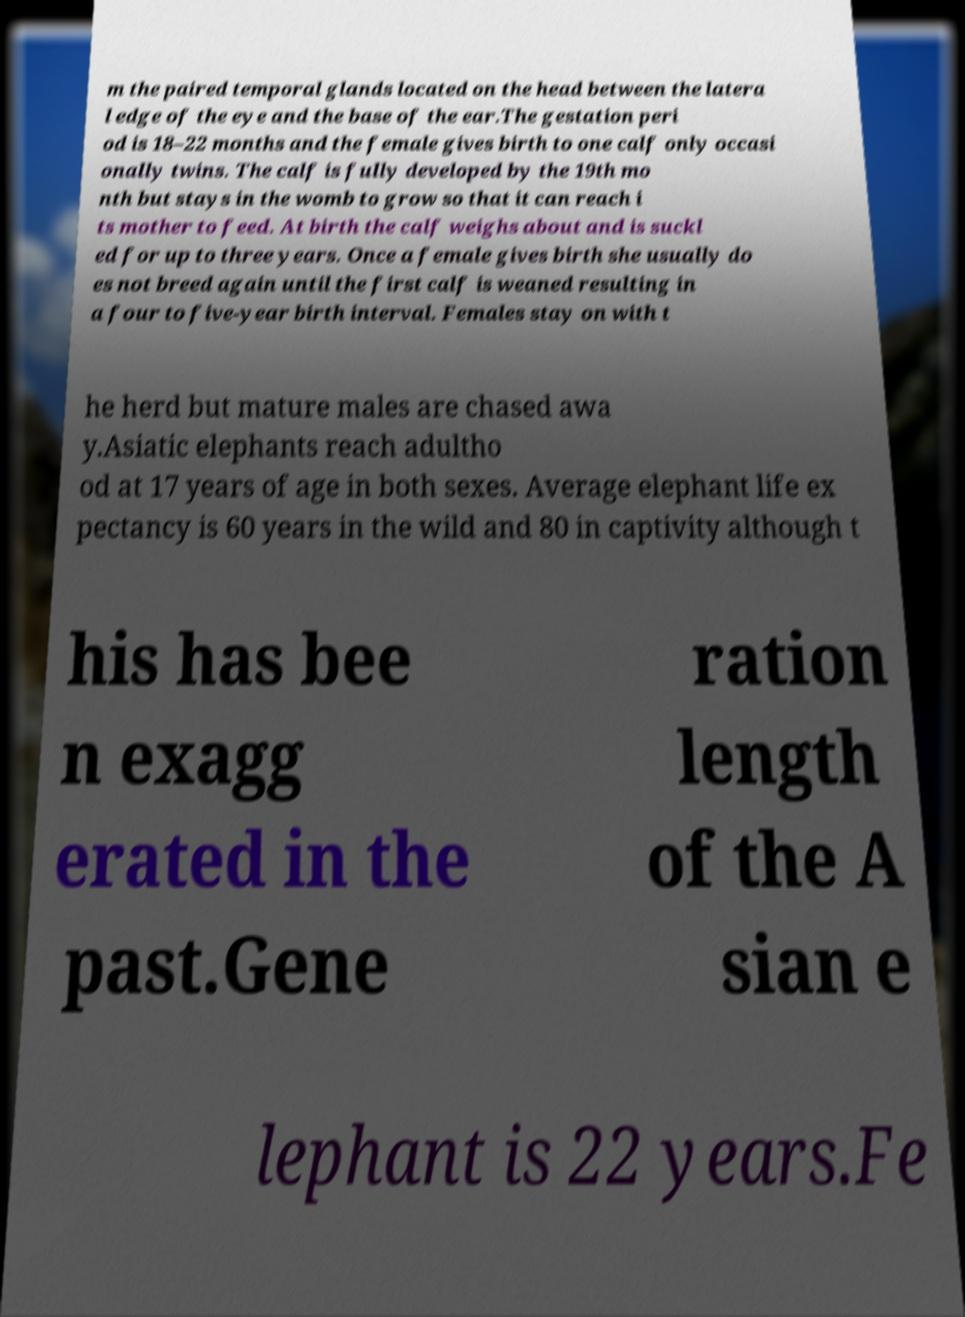Can you accurately transcribe the text from the provided image for me? m the paired temporal glands located on the head between the latera l edge of the eye and the base of the ear.The gestation peri od is 18–22 months and the female gives birth to one calf only occasi onally twins. The calf is fully developed by the 19th mo nth but stays in the womb to grow so that it can reach i ts mother to feed. At birth the calf weighs about and is suckl ed for up to three years. Once a female gives birth she usually do es not breed again until the first calf is weaned resulting in a four to five-year birth interval. Females stay on with t he herd but mature males are chased awa y.Asiatic elephants reach adultho od at 17 years of age in both sexes. Average elephant life ex pectancy is 60 years in the wild and 80 in captivity although t his has bee n exagg erated in the past.Gene ration length of the A sian e lephant is 22 years.Fe 